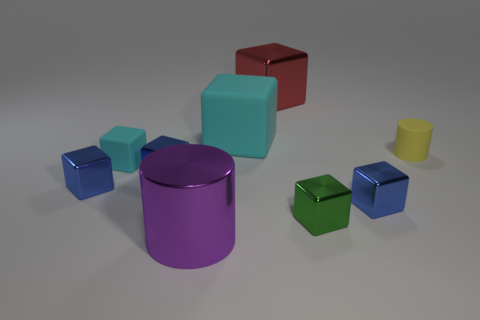There is a thing that is the same color as the large rubber cube; what is its shape?
Ensure brevity in your answer.  Cube. Are there more tiny yellow objects behind the tiny rubber cylinder than tiny blue objects?
Ensure brevity in your answer.  No. What is the size of the other cyan object that is made of the same material as the tiny cyan object?
Your answer should be compact. Large. There is a large cyan rubber block; are there any large metallic things behind it?
Offer a very short reply. Yes. Is the tiny yellow thing the same shape as the red object?
Offer a terse response. No. What is the size of the metallic object that is behind the cyan cube behind the cylinder that is to the right of the large purple thing?
Your answer should be compact. Large. What is the material of the yellow cylinder?
Ensure brevity in your answer.  Rubber. There is another cube that is the same color as the large rubber cube; what is its size?
Provide a succinct answer. Small. Does the small green object have the same shape as the cyan matte object that is right of the big purple cylinder?
Your answer should be very brief. Yes. What material is the cyan block in front of the rubber object right of the tiny blue metallic thing that is right of the small green metallic cube?
Make the answer very short. Rubber. 